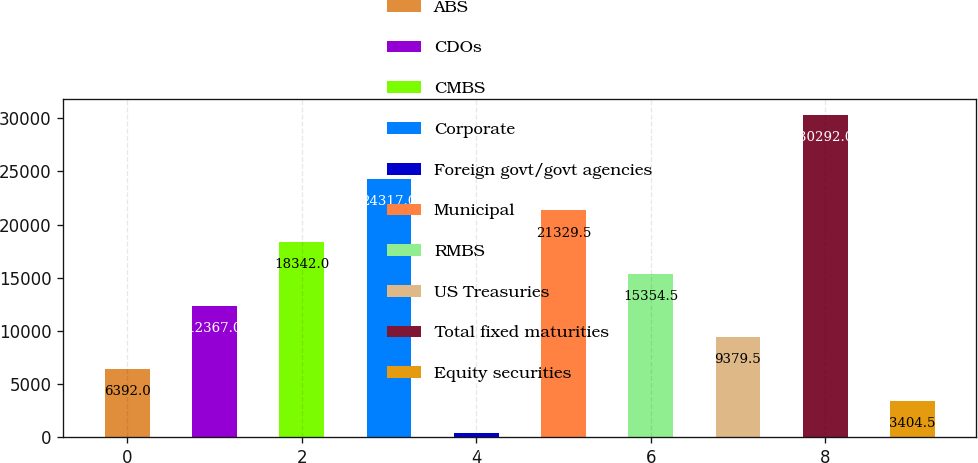Convert chart. <chart><loc_0><loc_0><loc_500><loc_500><bar_chart><fcel>ABS<fcel>CDOs<fcel>CMBS<fcel>Corporate<fcel>Foreign govt/govt agencies<fcel>Municipal<fcel>RMBS<fcel>US Treasuries<fcel>Total fixed maturities<fcel>Equity securities<nl><fcel>6392<fcel>12367<fcel>18342<fcel>24317<fcel>417<fcel>21329.5<fcel>15354.5<fcel>9379.5<fcel>30292<fcel>3404.5<nl></chart> 